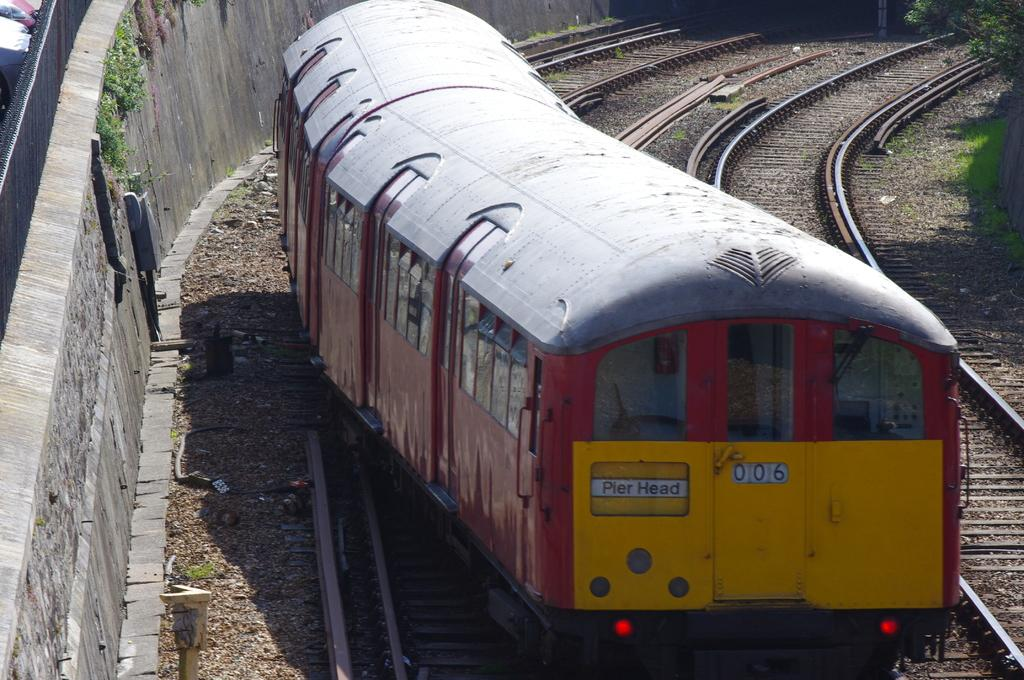What is the main subject of the image? There is a train in the image. What is the train's position in relation to the track? The train is on a track. What colors are used to paint the train? The train is red and yellow in color. What can be seen in the background of the image? There is a wall and trees visible in the image. What type of canvas is being used to repair the train in the image? There is no canvas or repair work being done on the train in the image. Can you tell me how many wrenches are visible in the image? There are no wrenches present in the image. 